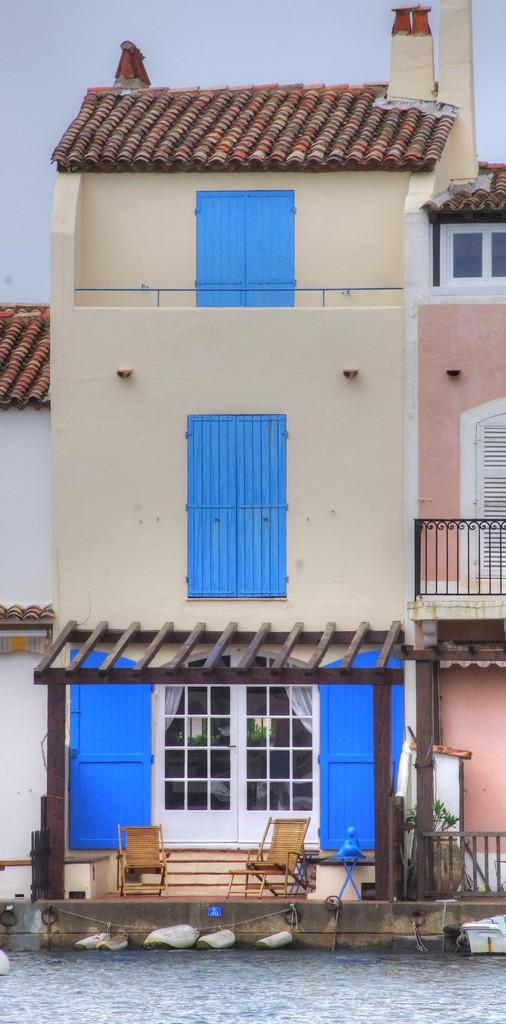What is the primary element in the image? There is water in the image. What can be seen floating on the water? There are white colored objects on the water. What type of furniture is present in the image? There are chairs in the image. What feature is used to prevent people from falling off the area? The railing is visible in the image. What structures are visible in the background? There are buildings in the image. What part of the natural environment is visible in the background? The sky is visible in the background of the image. How much money is being exchanged between the boy and the vendor in the image? There is no boy or vendor present in the image, so no money exchange can be observed. 